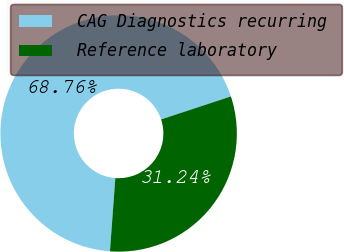Convert chart. <chart><loc_0><loc_0><loc_500><loc_500><pie_chart><fcel>CAG Diagnostics recurring<fcel>Reference laboratory<nl><fcel>68.76%<fcel>31.24%<nl></chart> 